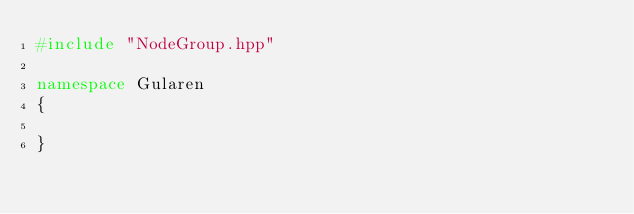Convert code to text. <code><loc_0><loc_0><loc_500><loc_500><_C++_>#include "NodeGroup.hpp"

namespace Gularen
{

}
</code> 